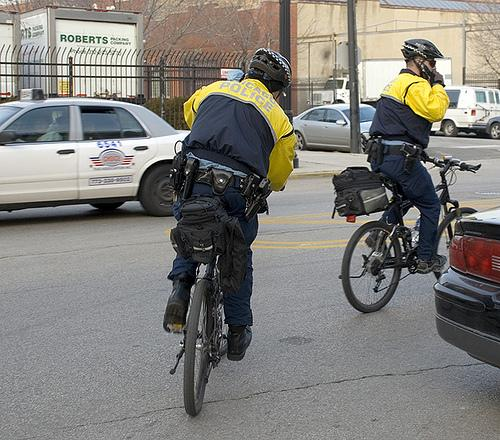What profession are the men on bikes? Please explain your reasoning. police officers. The men are wearing police jackets. 